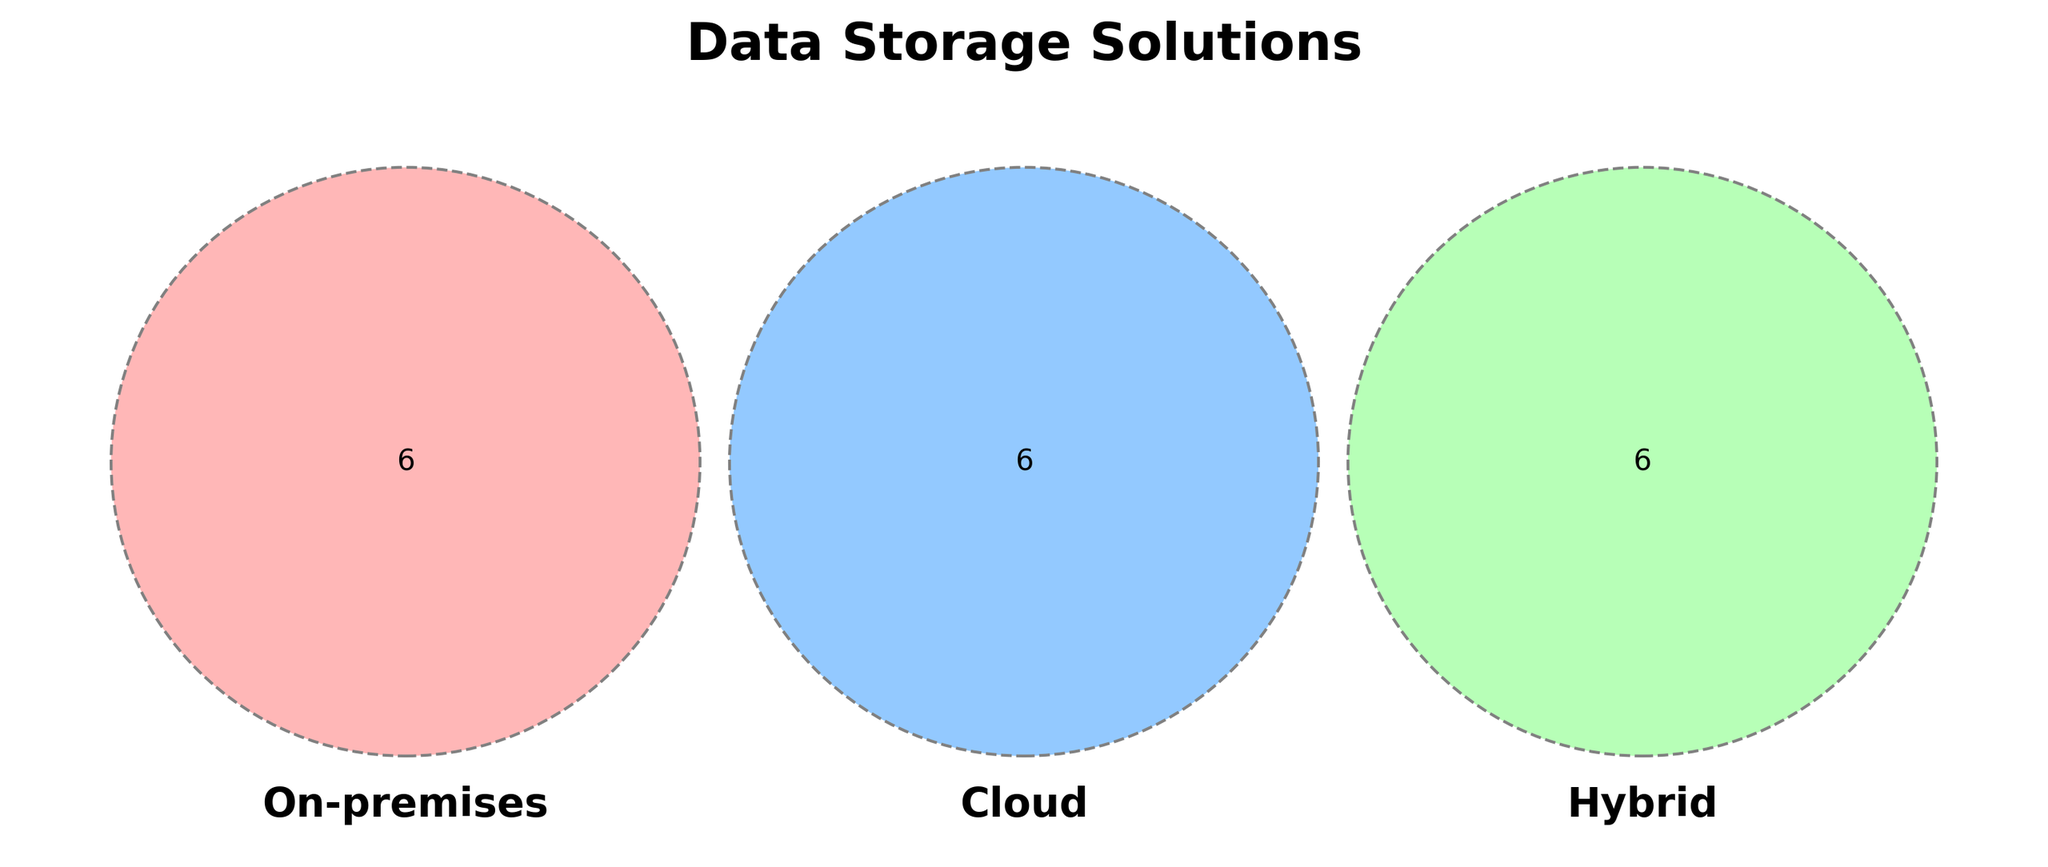What is the title of the diagram? The title is displayed at the top of the diagram in bold. It reads "Data Storage Solutions".
Answer: Data Storage Solutions How many sets are there in the Venn diagram? There are three sets in the Venn diagram, each represented by an overlapping circle.
Answer: Three Which storage location features "Legacy systems"? The segment of the Venn diagram labeled "On-premises" contains the feature "Legacy systems".
Answer: On-premises What feature is shared by all three storage solutions? The diagram does not show any feature that is common to all three sets by the absence of texts in the central intersection.
Answer: None Which solution offers "Automatic backups"? The "Cloud" segment of the Venn diagram includes the feature "Automatic backups".
Answer: Cloud How many features are unique to the Hybrid system? The Venn diagram shows six unique features listed under the "Hybrid" section.
Answer: Six Does any feature appear in both On-premises and Cloud but not in Hybrid? By checking the overlapping areas of On-premises and Cloud without Hybrid, there is no such feature indicated.
Answer: No Which solution has the feature "Global availability"? The "Cloud" section of the Venn diagram includes the feature "Global availability".
Answer: Cloud Are there any intersecting features between Hybrid and Cloud? The Venn diagram visual indicates no shared features between Hybrid and Cloud alone, as there are no texts in the overlapping section of these two.
Answer: No What storage location handles "Hardware maintenance"? The "On-premises" segment of the Venn diagram includes the feature "Hardware maintenance".
Answer: On-premises 